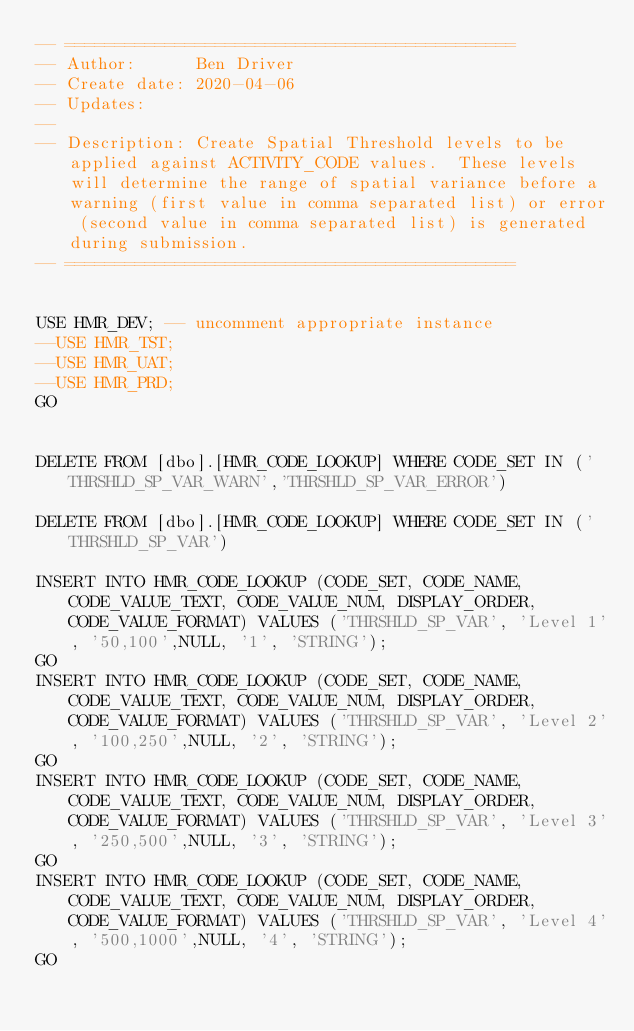<code> <loc_0><loc_0><loc_500><loc_500><_SQL_>-- =============================================
-- Author:		Ben Driver
-- Create date: 2020-04-06
-- Updates: 
-- 
-- Description:	Create Spatial Threshold levels to be applied against ACTIVITY_CODE values.  These levels will determine the range of spatial variance before a warning (first value in comma separated list) or error (second value in comma separated list) is generated during submission.
-- =============================================


USE HMR_DEV; -- uncomment appropriate instance
--USE HMR_TST;
--USE HMR_UAT;
--USE HMR_PRD;
GO


DELETE FROM [dbo].[HMR_CODE_LOOKUP] WHERE CODE_SET IN ('THRSHLD_SP_VAR_WARN','THRSHLD_SP_VAR_ERROR')

DELETE FROM [dbo].[HMR_CODE_LOOKUP] WHERE CODE_SET IN ('THRSHLD_SP_VAR')

INSERT INTO HMR_CODE_LOOKUP (CODE_SET, CODE_NAME, CODE_VALUE_TEXT, CODE_VALUE_NUM, DISPLAY_ORDER, CODE_VALUE_FORMAT) VALUES ('THRSHLD_SP_VAR', 'Level 1', '50,100',NULL, '1', 'STRING');
GO
INSERT INTO HMR_CODE_LOOKUP (CODE_SET, CODE_NAME, CODE_VALUE_TEXT, CODE_VALUE_NUM, DISPLAY_ORDER, CODE_VALUE_FORMAT) VALUES ('THRSHLD_SP_VAR', 'Level 2', '100,250',NULL, '2', 'STRING');
GO
INSERT INTO HMR_CODE_LOOKUP (CODE_SET, CODE_NAME, CODE_VALUE_TEXT, CODE_VALUE_NUM, DISPLAY_ORDER, CODE_VALUE_FORMAT) VALUES ('THRSHLD_SP_VAR', 'Level 3', '250,500',NULL, '3', 'STRING');
GO
INSERT INTO HMR_CODE_LOOKUP (CODE_SET, CODE_NAME, CODE_VALUE_TEXT, CODE_VALUE_NUM, DISPLAY_ORDER, CODE_VALUE_FORMAT) VALUES ('THRSHLD_SP_VAR', 'Level 4', '500,1000',NULL, '4', 'STRING');
GO

</code> 